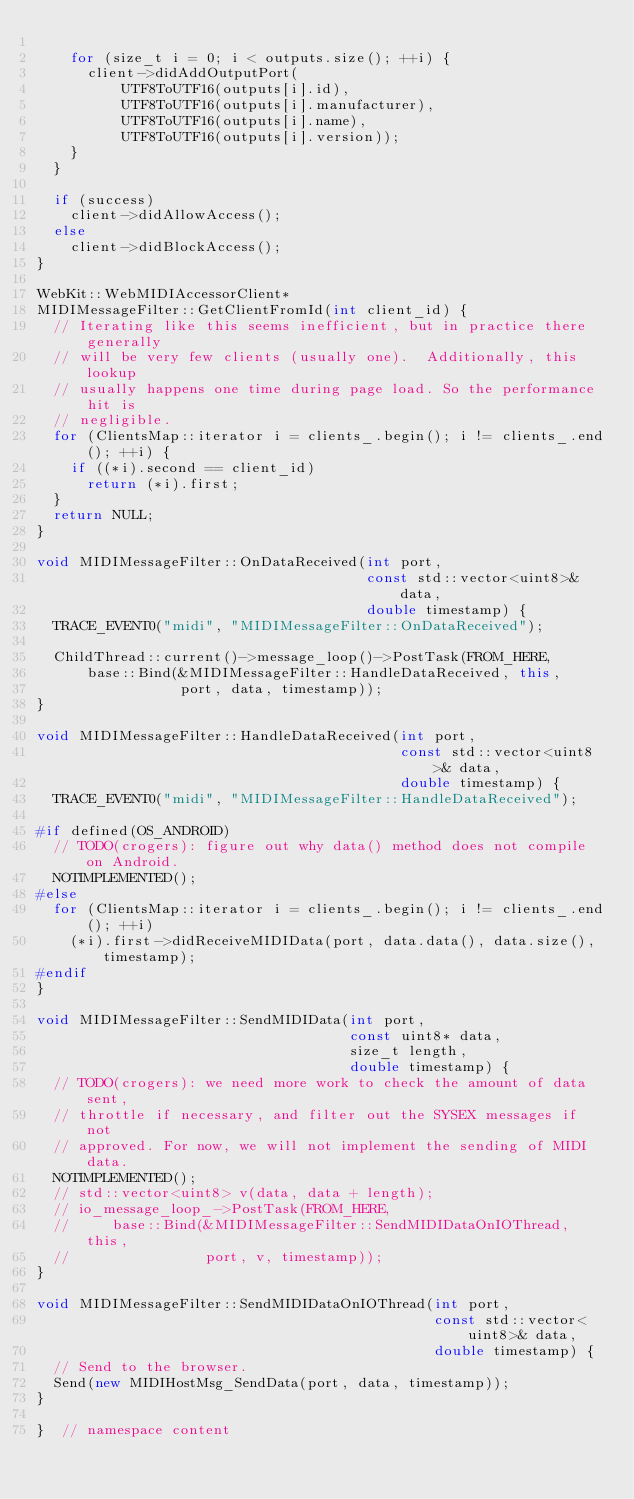Convert code to text. <code><loc_0><loc_0><loc_500><loc_500><_C++_>
    for (size_t i = 0; i < outputs.size(); ++i) {
      client->didAddOutputPort(
          UTF8ToUTF16(outputs[i].id),
          UTF8ToUTF16(outputs[i].manufacturer),
          UTF8ToUTF16(outputs[i].name),
          UTF8ToUTF16(outputs[i].version));
    }
  }

  if (success)
    client->didAllowAccess();
  else
    client->didBlockAccess();
}

WebKit::WebMIDIAccessorClient*
MIDIMessageFilter::GetClientFromId(int client_id) {
  // Iterating like this seems inefficient, but in practice there generally
  // will be very few clients (usually one).  Additionally, this lookup
  // usually happens one time during page load. So the performance hit is
  // negligible.
  for (ClientsMap::iterator i = clients_.begin(); i != clients_.end(); ++i) {
    if ((*i).second == client_id)
      return (*i).first;
  }
  return NULL;
}

void MIDIMessageFilter::OnDataReceived(int port,
                                       const std::vector<uint8>& data,
                                       double timestamp) {
  TRACE_EVENT0("midi", "MIDIMessageFilter::OnDataReceived");

  ChildThread::current()->message_loop()->PostTask(FROM_HERE,
      base::Bind(&MIDIMessageFilter::HandleDataReceived, this,
                 port, data, timestamp));
}

void MIDIMessageFilter::HandleDataReceived(int port,
                                           const std::vector<uint8>& data,
                                           double timestamp) {
  TRACE_EVENT0("midi", "MIDIMessageFilter::HandleDataReceived");

#if defined(OS_ANDROID)
  // TODO(crogers): figure out why data() method does not compile on Android.
  NOTIMPLEMENTED();
#else
  for (ClientsMap::iterator i = clients_.begin(); i != clients_.end(); ++i)
    (*i).first->didReceiveMIDIData(port, data.data(), data.size(), timestamp);
#endif
}

void MIDIMessageFilter::SendMIDIData(int port,
                                     const uint8* data,
                                     size_t length,
                                     double timestamp) {
  // TODO(crogers): we need more work to check the amount of data sent,
  // throttle if necessary, and filter out the SYSEX messages if not
  // approved. For now, we will not implement the sending of MIDI data.
  NOTIMPLEMENTED();
  // std::vector<uint8> v(data, data + length);
  // io_message_loop_->PostTask(FROM_HERE,
  //     base::Bind(&MIDIMessageFilter::SendMIDIDataOnIOThread, this,
  //                port, v, timestamp));
}

void MIDIMessageFilter::SendMIDIDataOnIOThread(int port,
                                               const std::vector<uint8>& data,
                                               double timestamp) {
  // Send to the browser.
  Send(new MIDIHostMsg_SendData(port, data, timestamp));
}

}  // namespace content
</code> 